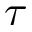Convert formula to latex. <formula><loc_0><loc_0><loc_500><loc_500>\tau</formula> 